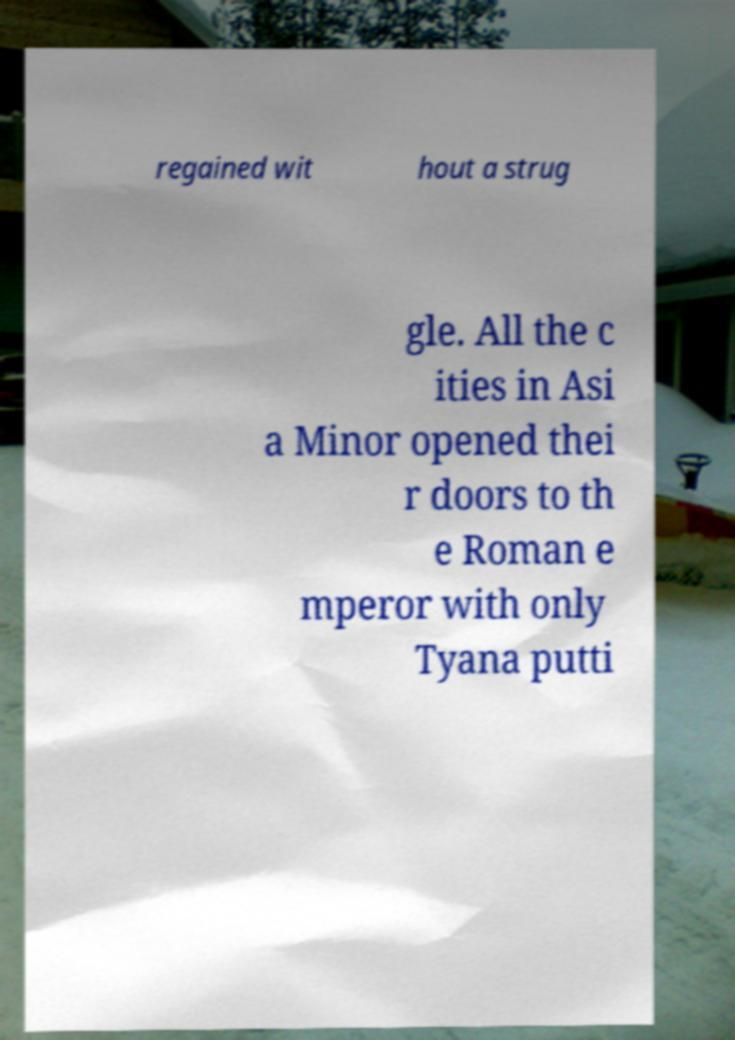Can you read and provide the text displayed in the image?This photo seems to have some interesting text. Can you extract and type it out for me? regained wit hout a strug gle. All the c ities in Asi a Minor opened thei r doors to th e Roman e mperor with only Tyana putti 